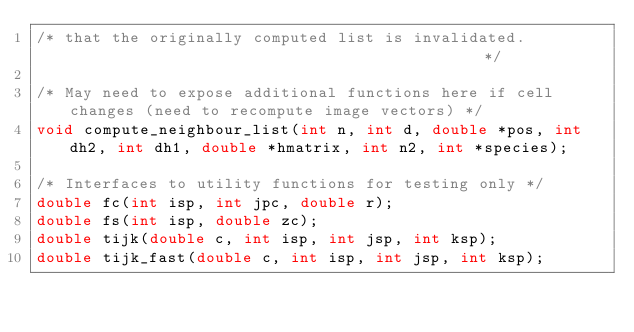Convert code to text. <code><loc_0><loc_0><loc_500><loc_500><_C_>/* that the originally computed list is invalidated.                                             */

/* May need to expose additional functions here if cell changes (need to recompute image vectors) */
void compute_neighbour_list(int n, int d, double *pos, int dh2, int dh1, double *hmatrix, int n2, int *species);

/* Interfaces to utility functions for testing only */
double fc(int isp, int jpc, double r);
double fs(int isp, double zc);
double tijk(double c, int isp, int jsp, int ksp);
double tijk_fast(double c, int isp, int jsp, int ksp); 
</code> 